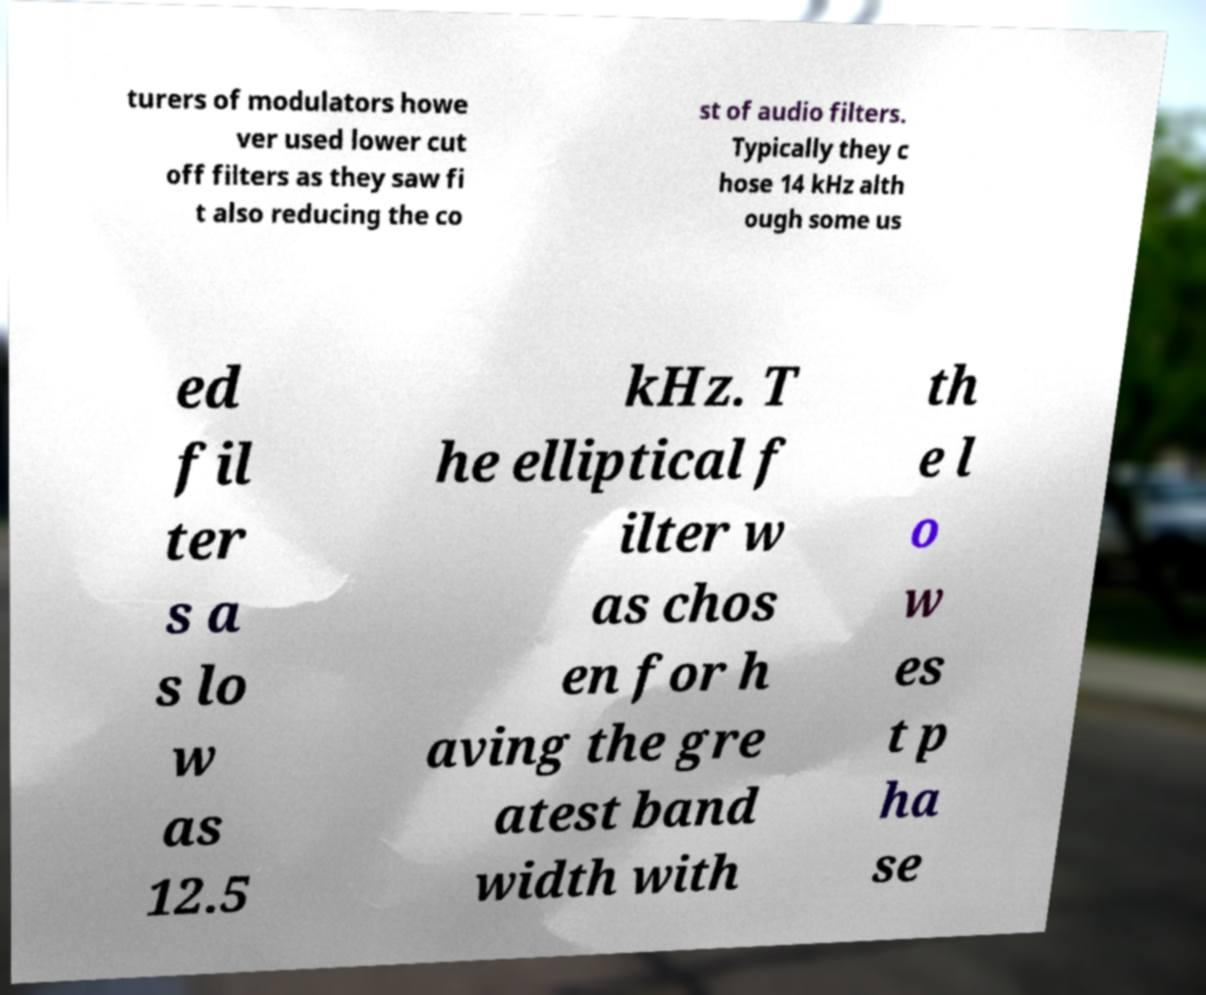I need the written content from this picture converted into text. Can you do that? turers of modulators howe ver used lower cut off filters as they saw fi t also reducing the co st of audio filters. Typically they c hose 14 kHz alth ough some us ed fil ter s a s lo w as 12.5 kHz. T he elliptical f ilter w as chos en for h aving the gre atest band width with th e l o w es t p ha se 